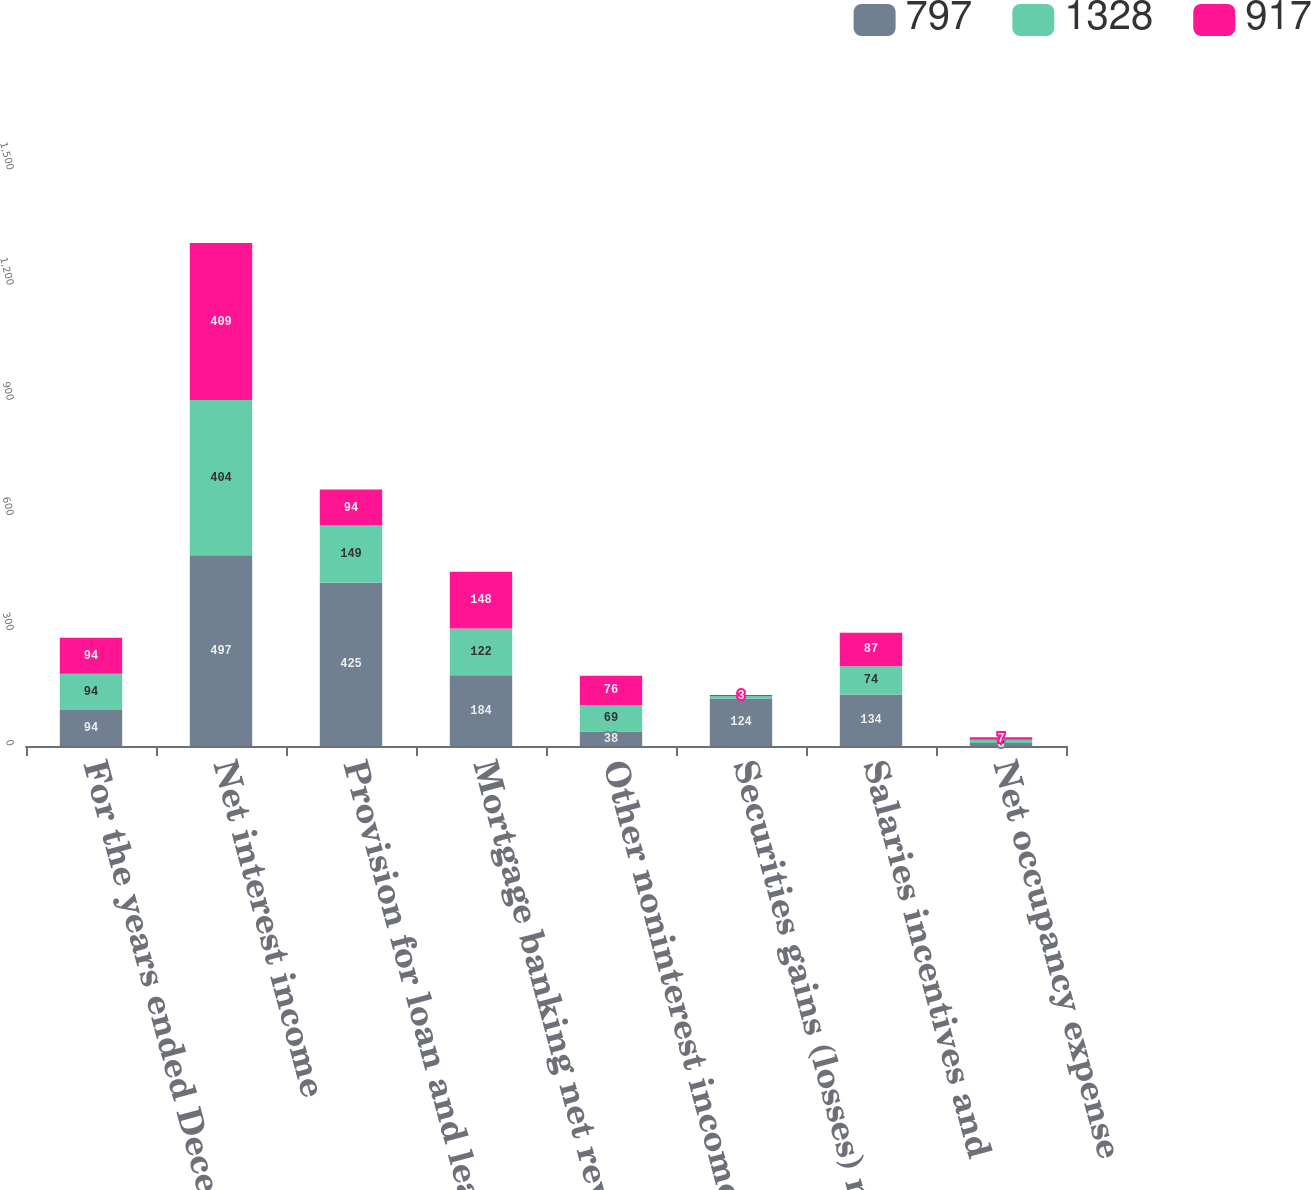<chart> <loc_0><loc_0><loc_500><loc_500><stacked_bar_chart><ecel><fcel>For the years ended December<fcel>Net interest income<fcel>Provision for loan and lease<fcel>Mortgage banking net revenue<fcel>Other noninterest income<fcel>Securities gains (losses) net<fcel>Salaries incentives and<fcel>Net occupancy expense<nl><fcel>797<fcel>94<fcel>497<fcel>425<fcel>184<fcel>38<fcel>124<fcel>134<fcel>8<nl><fcel>1328<fcel>94<fcel>404<fcel>149<fcel>122<fcel>69<fcel>6<fcel>74<fcel>8<nl><fcel>917<fcel>94<fcel>409<fcel>94<fcel>148<fcel>76<fcel>3<fcel>87<fcel>7<nl></chart> 